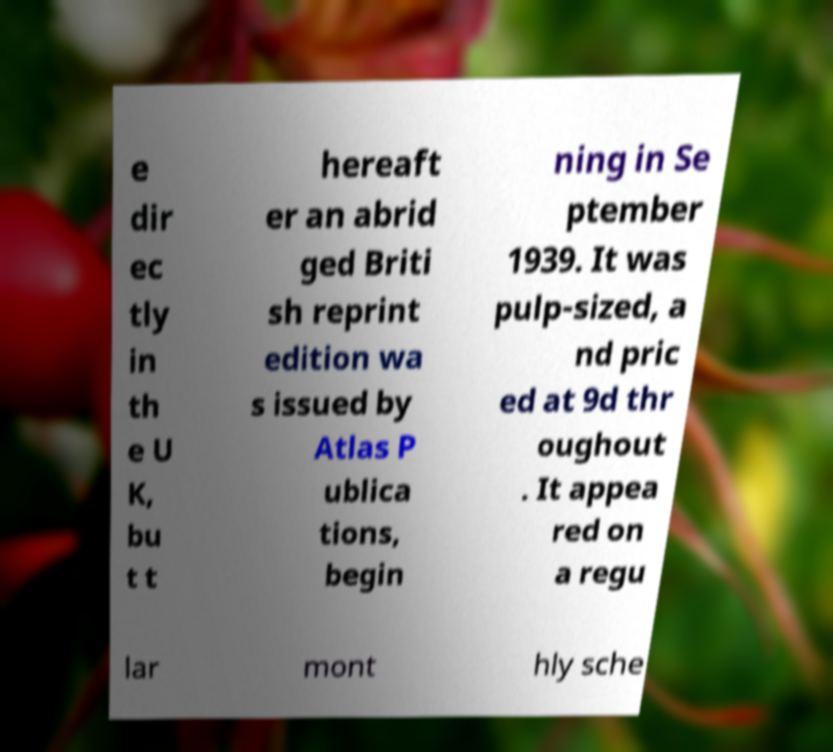Could you extract and type out the text from this image? e dir ec tly in th e U K, bu t t hereaft er an abrid ged Briti sh reprint edition wa s issued by Atlas P ublica tions, begin ning in Se ptember 1939. It was pulp-sized, a nd pric ed at 9d thr oughout . It appea red on a regu lar mont hly sche 